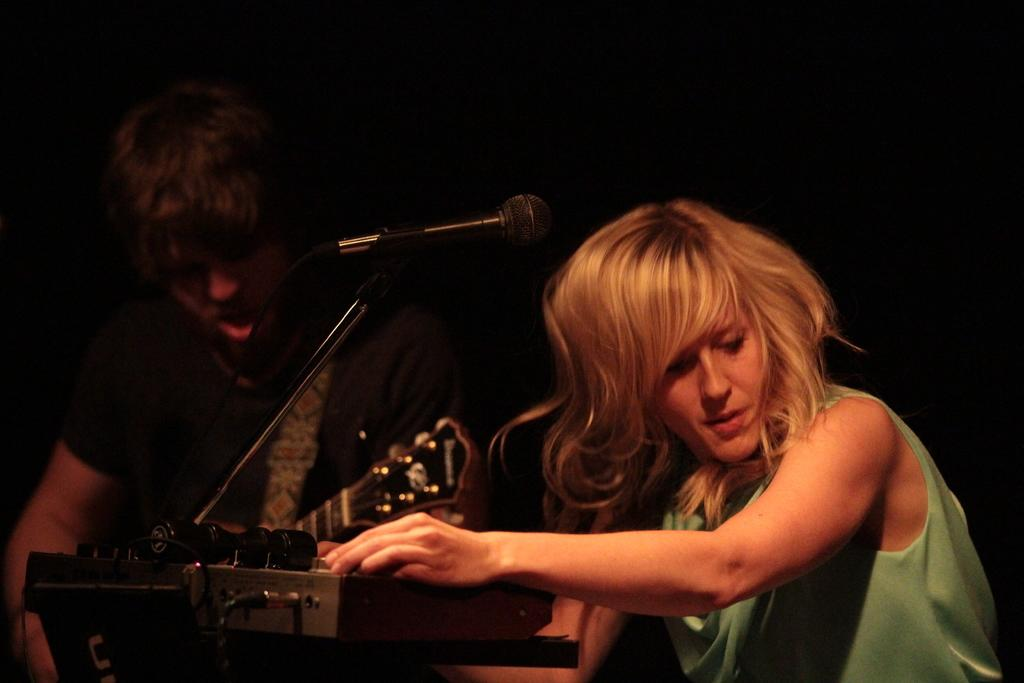How many people are in the image? There are two persons in the image. What is the background like in the image? The persons are on a dark background. What are the persons wearing? The persons are wearing clothes. What object is in the middle of the image? There is a microphone in the middle of the image. Can you see a rat interacting with the microphone in the image? There is no rat present in the image, and therefore no such interaction can be observed. 